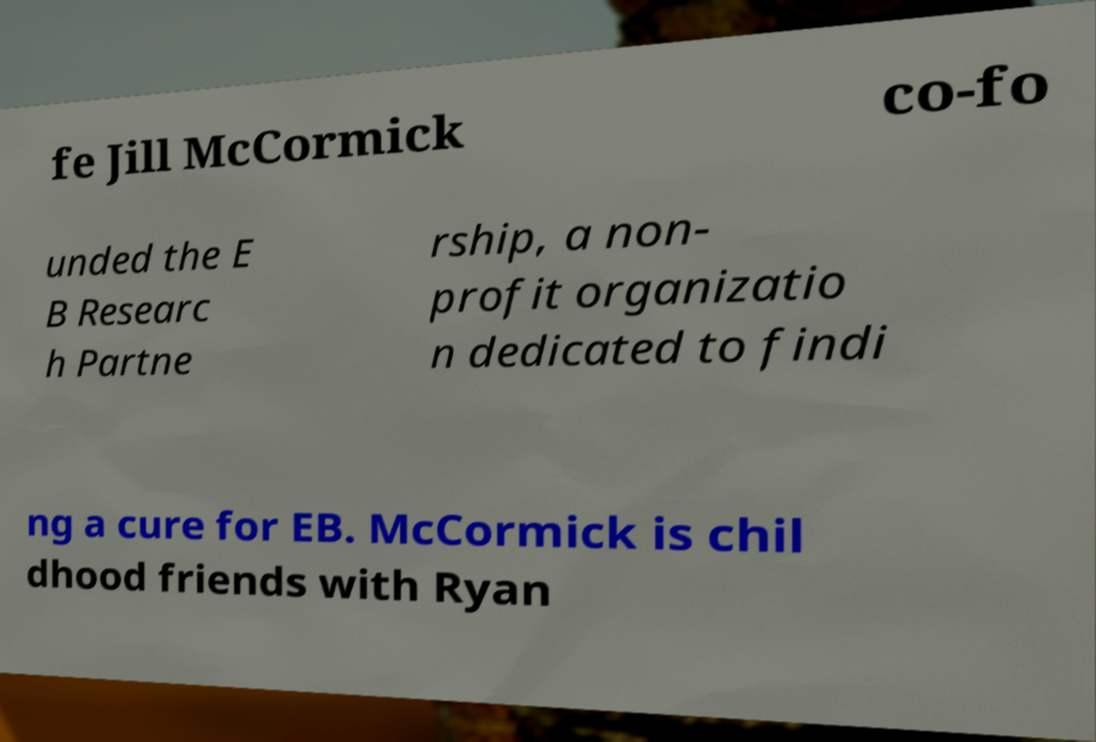Please read and relay the text visible in this image. What does it say? fe Jill McCormick co-fo unded the E B Researc h Partne rship, a non- profit organizatio n dedicated to findi ng a cure for EB. McCormick is chil dhood friends with Ryan 